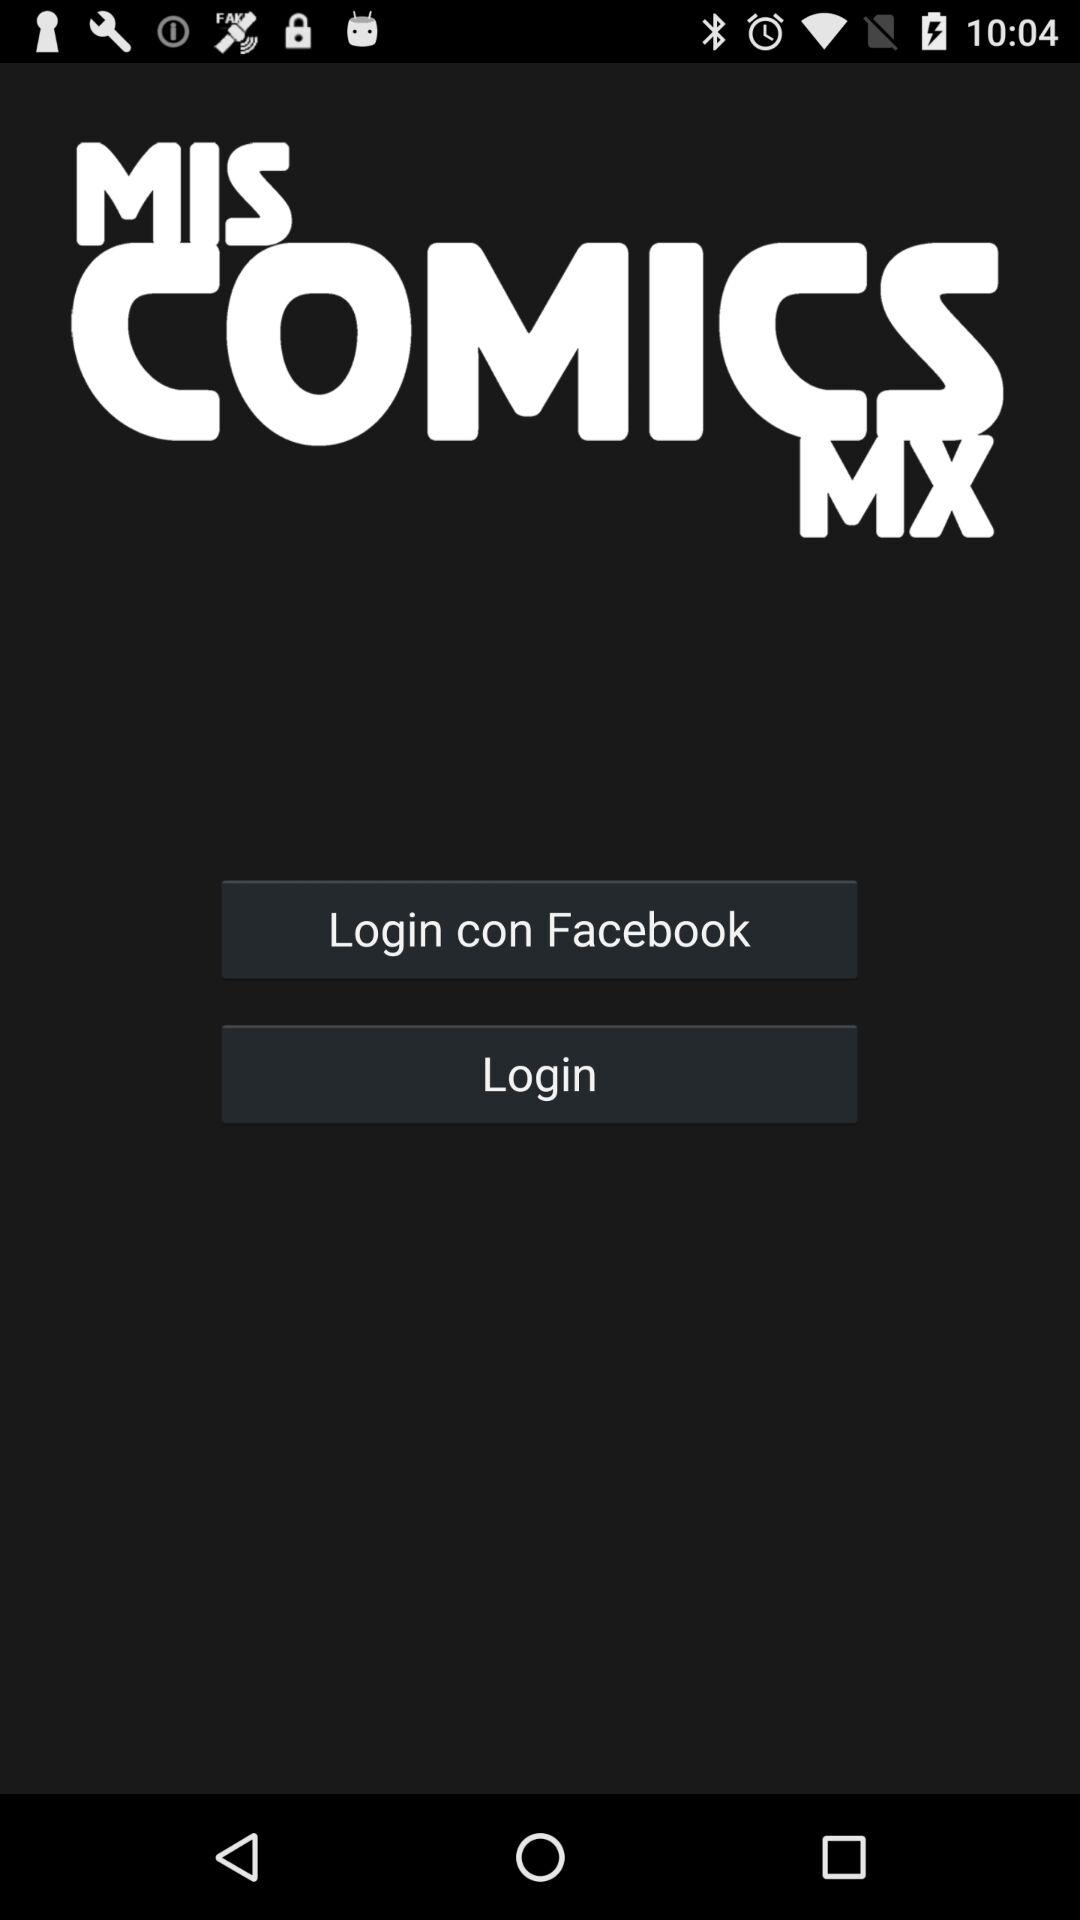What is the application name? The application name is "MIS COMICS MX". 